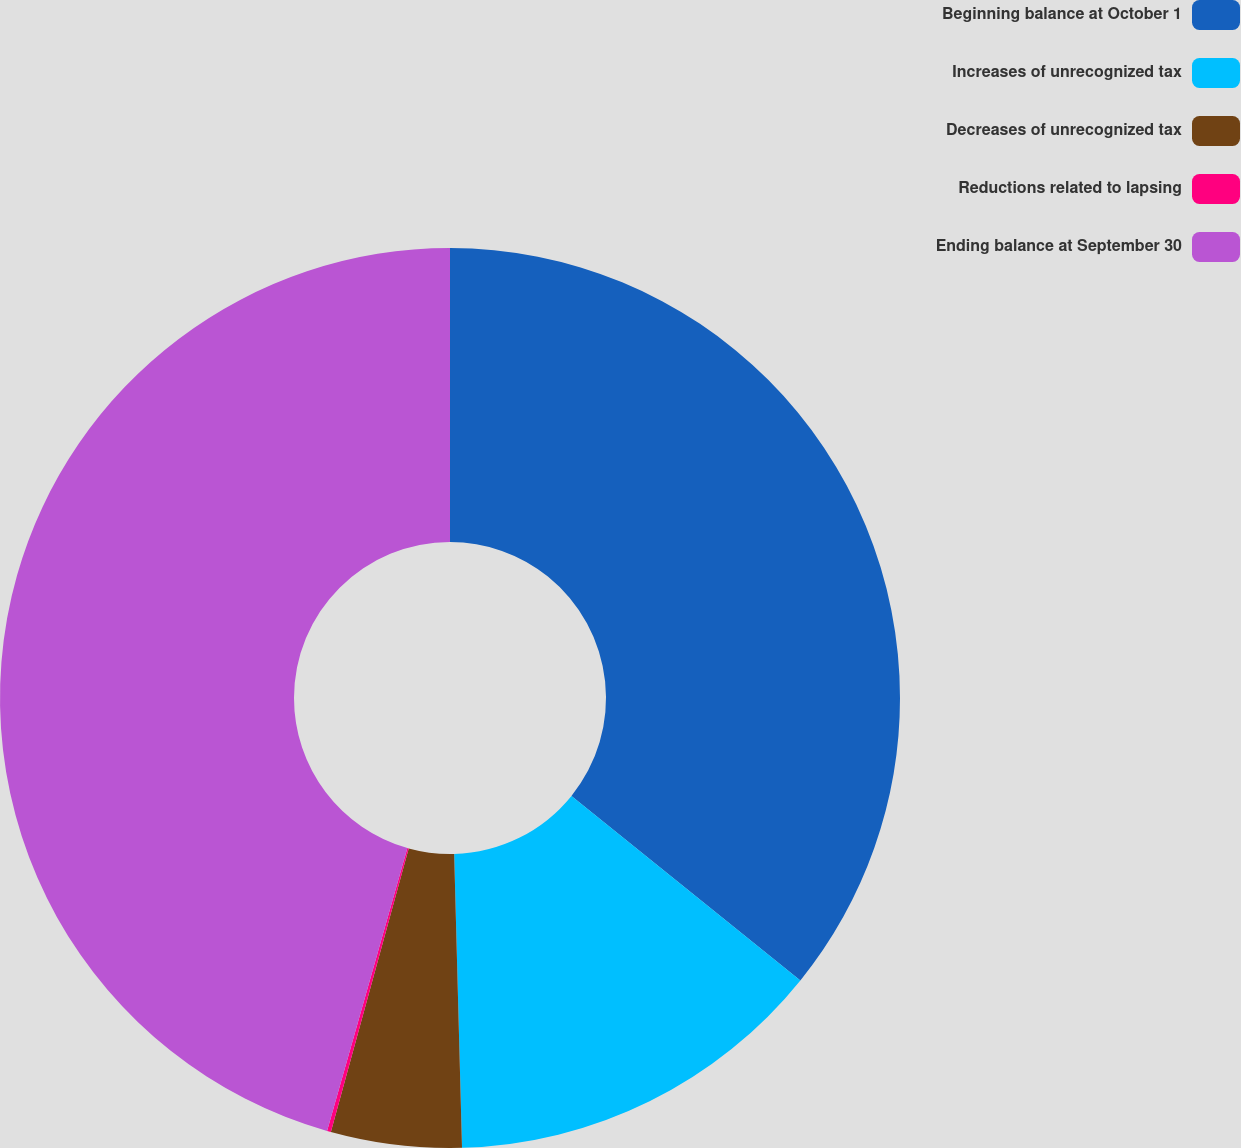<chart> <loc_0><loc_0><loc_500><loc_500><pie_chart><fcel>Beginning balance at October 1<fcel>Increases of unrecognized tax<fcel>Decreases of unrecognized tax<fcel>Reductions related to lapsing<fcel>Ending balance at September 30<nl><fcel>35.8%<fcel>13.78%<fcel>4.69%<fcel>0.14%<fcel>45.6%<nl></chart> 